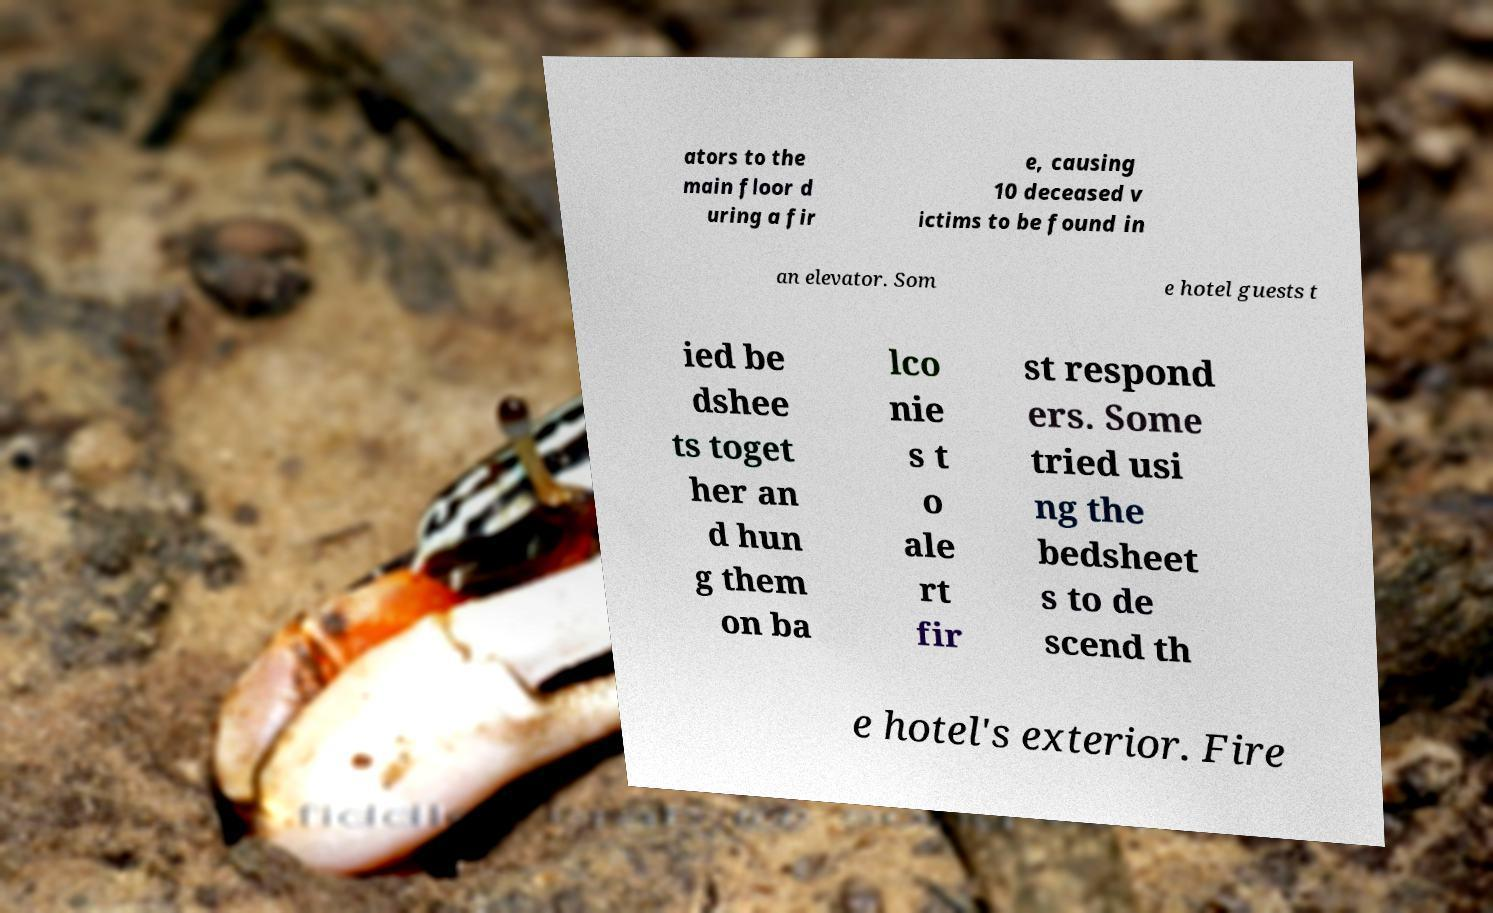Could you assist in decoding the text presented in this image and type it out clearly? ators to the main floor d uring a fir e, causing 10 deceased v ictims to be found in an elevator. Som e hotel guests t ied be dshee ts toget her an d hun g them on ba lco nie s t o ale rt fir st respond ers. Some tried usi ng the bedsheet s to de scend th e hotel's exterior. Fire 